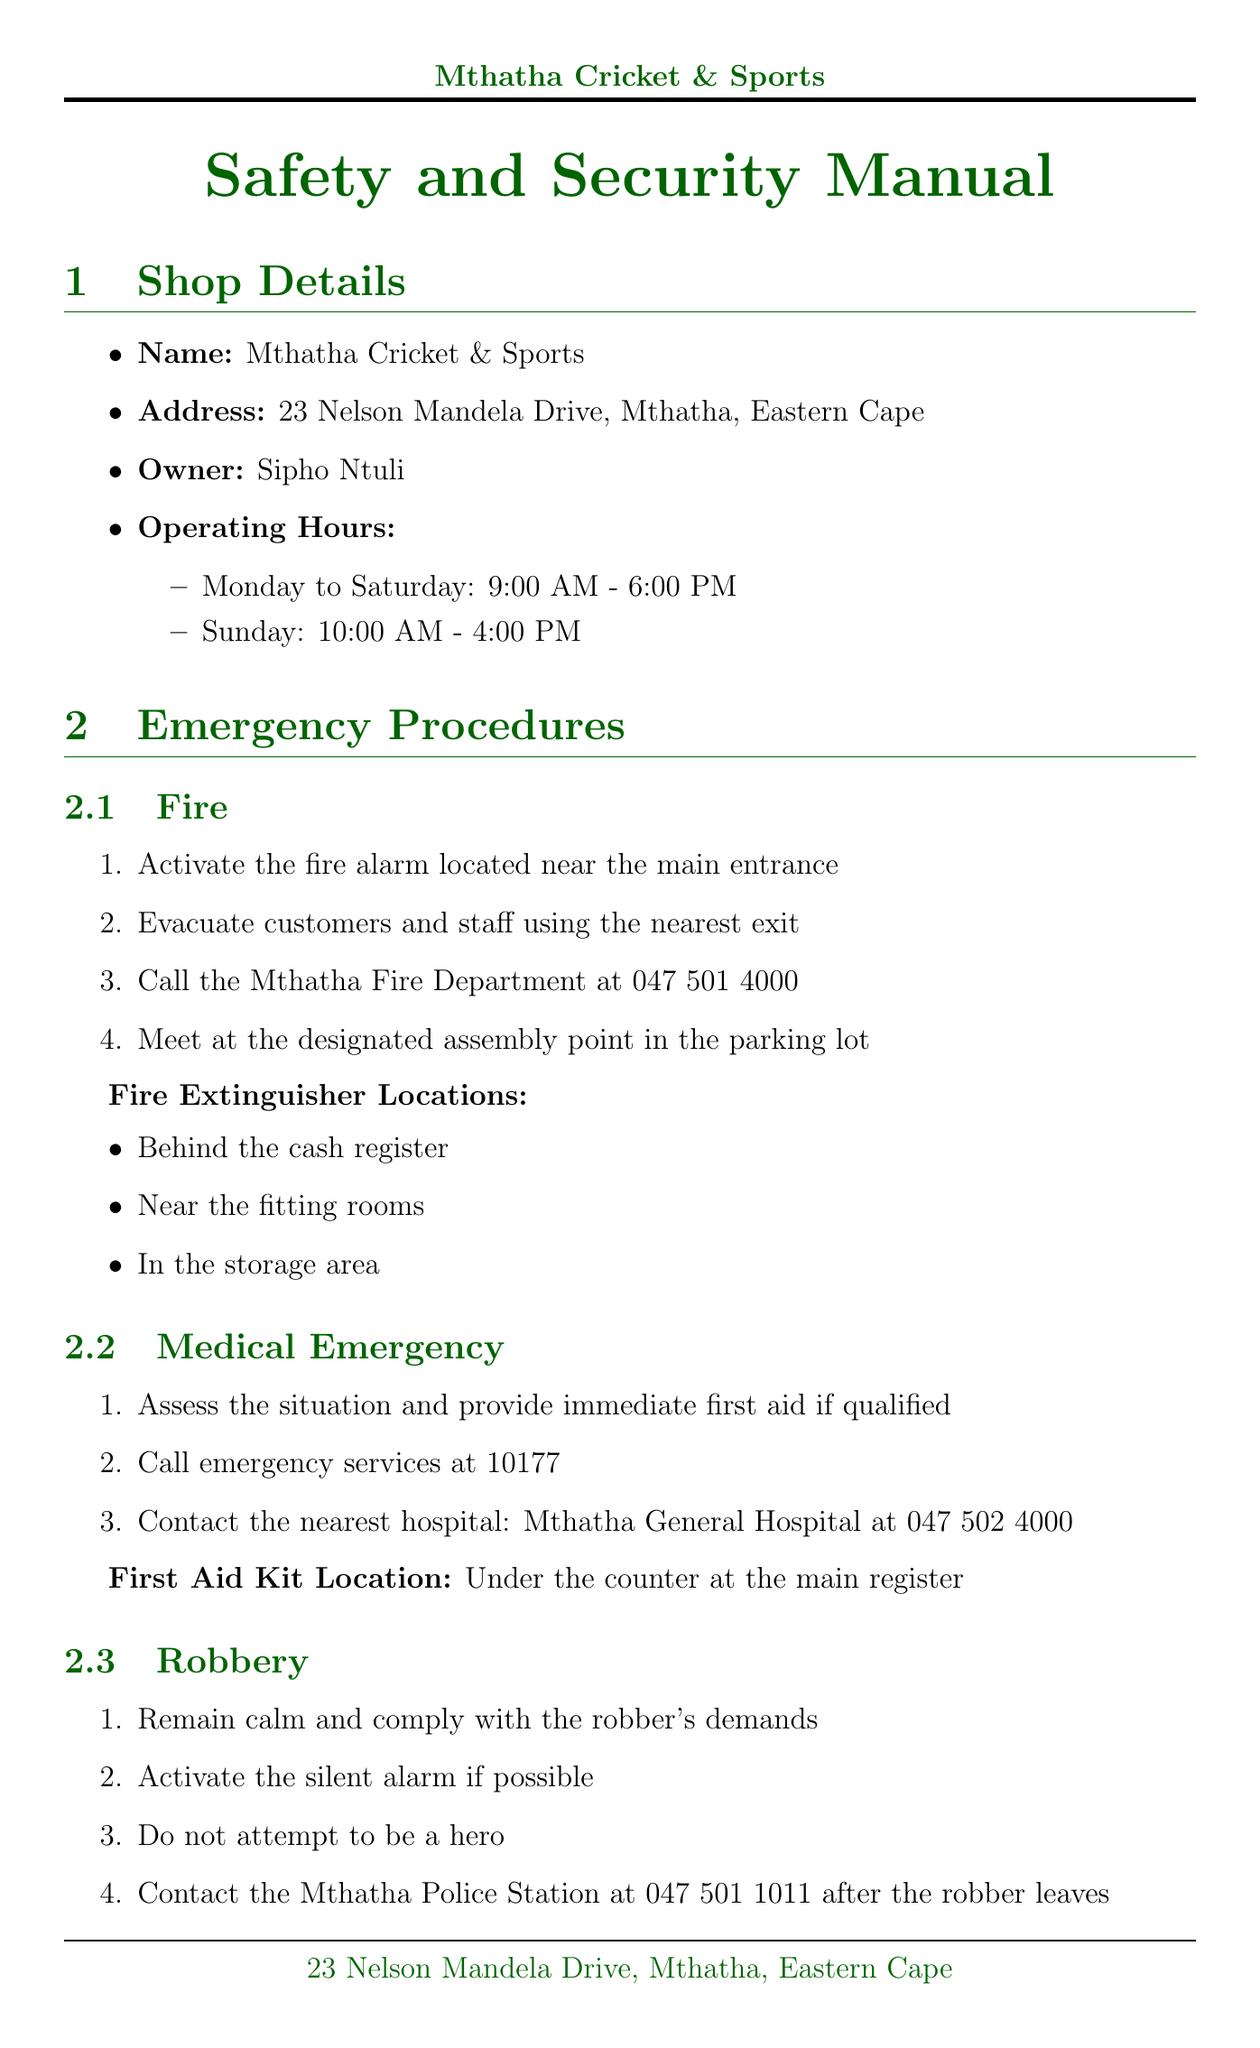What is the name of the shop? The name of the shop is listed clearly in the document as the primary subject.
Answer: Mthatha Cricket & Sports What is the operating hour on Sunday? The operating hours for Sunday are specifically stated in the document.
Answer: 10:00 AM - 4:00 PM Where is the first aid kit located? The document specifies the location of the first aid kit under the medical emergency procedures.
Answer: Under the counter at the main register How many cameras are in the CCTV system? The number of cameras is explicitly mentioned in the security measures section of the document.
Answer: 8 What should you do in case of a fire? The procedures for a fire emergency are outlined step-by-step in the manual.
Answer: Activate the fire alarm located near the main entrance What is the frequency for ongoing training? The training frequency is outlined in the employee training protocols section.
Answer: Monthly What are the high-risk items in inventory management? High-risk items are listed in the inventory management subsection.
Answer: Cricket bats, Jerseys, Running shoes What is the contact number for the ambulance? The contact number for emergency medical services is provided in the local emergency contacts section.
Answer: 10177 What are the emergency exits in the shop? The emergency exits are specifically mentioned under the shop layout section.
Answer: Main entrance, Rear door near storage area 